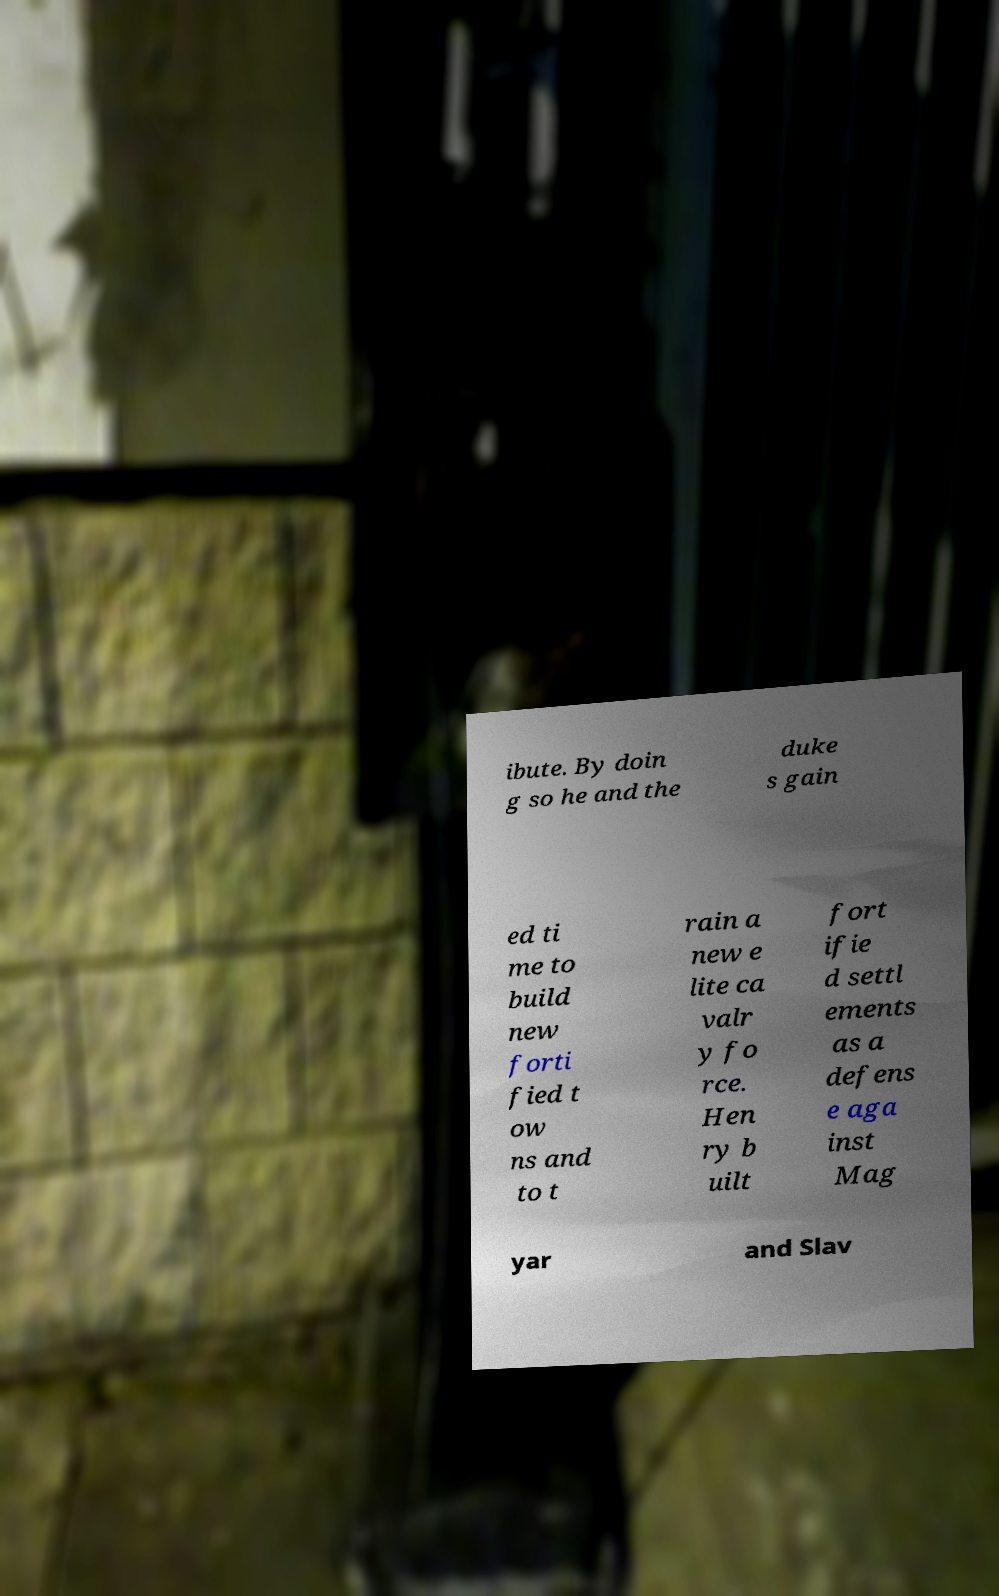Please identify and transcribe the text found in this image. ibute. By doin g so he and the duke s gain ed ti me to build new forti fied t ow ns and to t rain a new e lite ca valr y fo rce. Hen ry b uilt fort ifie d settl ements as a defens e aga inst Mag yar and Slav 